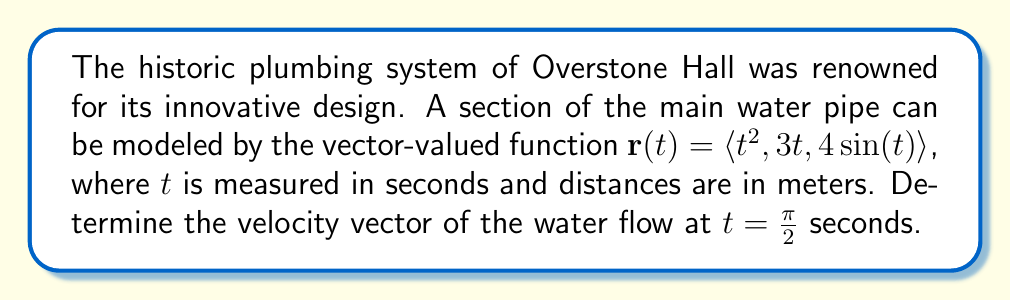Solve this math problem. To solve this problem, we need to follow these steps:

1) The velocity vector is given by the derivative of the position vector with respect to time. In other words, $\mathbf{v}(t) = \mathbf{r}'(t)$.

2) Let's differentiate each component of $\mathbf{r}(t)$:

   $\frac{d}{dt}(t^2) = 2t$
   $\frac{d}{dt}(3t) = 3$
   $\frac{d}{dt}(4\sin(t)) = 4\cos(t)$

3) Therefore, the velocity vector function is:

   $\mathbf{v}(t) = \langle 2t, 3, 4\cos(t) \rangle$

4) We need to evaluate this at $t = \frac{\pi}{2}$:

   $\mathbf{v}(\frac{\pi}{2}) = \langle 2(\frac{\pi}{2}), 3, 4\cos(\frac{\pi}{2}) \rangle$

5) Simplify:
   - $2(\frac{\pi}{2}) = \pi$
   - $\cos(\frac{\pi}{2}) = 0$

6) Therefore, the final velocity vector is:

   $\mathbf{v}(\frac{\pi}{2}) = \langle \pi, 3, 0 \rangle$

This vector represents the instantaneous velocity of the water flow at $t = \frac{\pi}{2}$ seconds in the historic plumbing system of Overstone Hall.
Answer: $\mathbf{v}(\frac{\pi}{2}) = \langle \pi, 3, 0 \rangle$ meters per second 